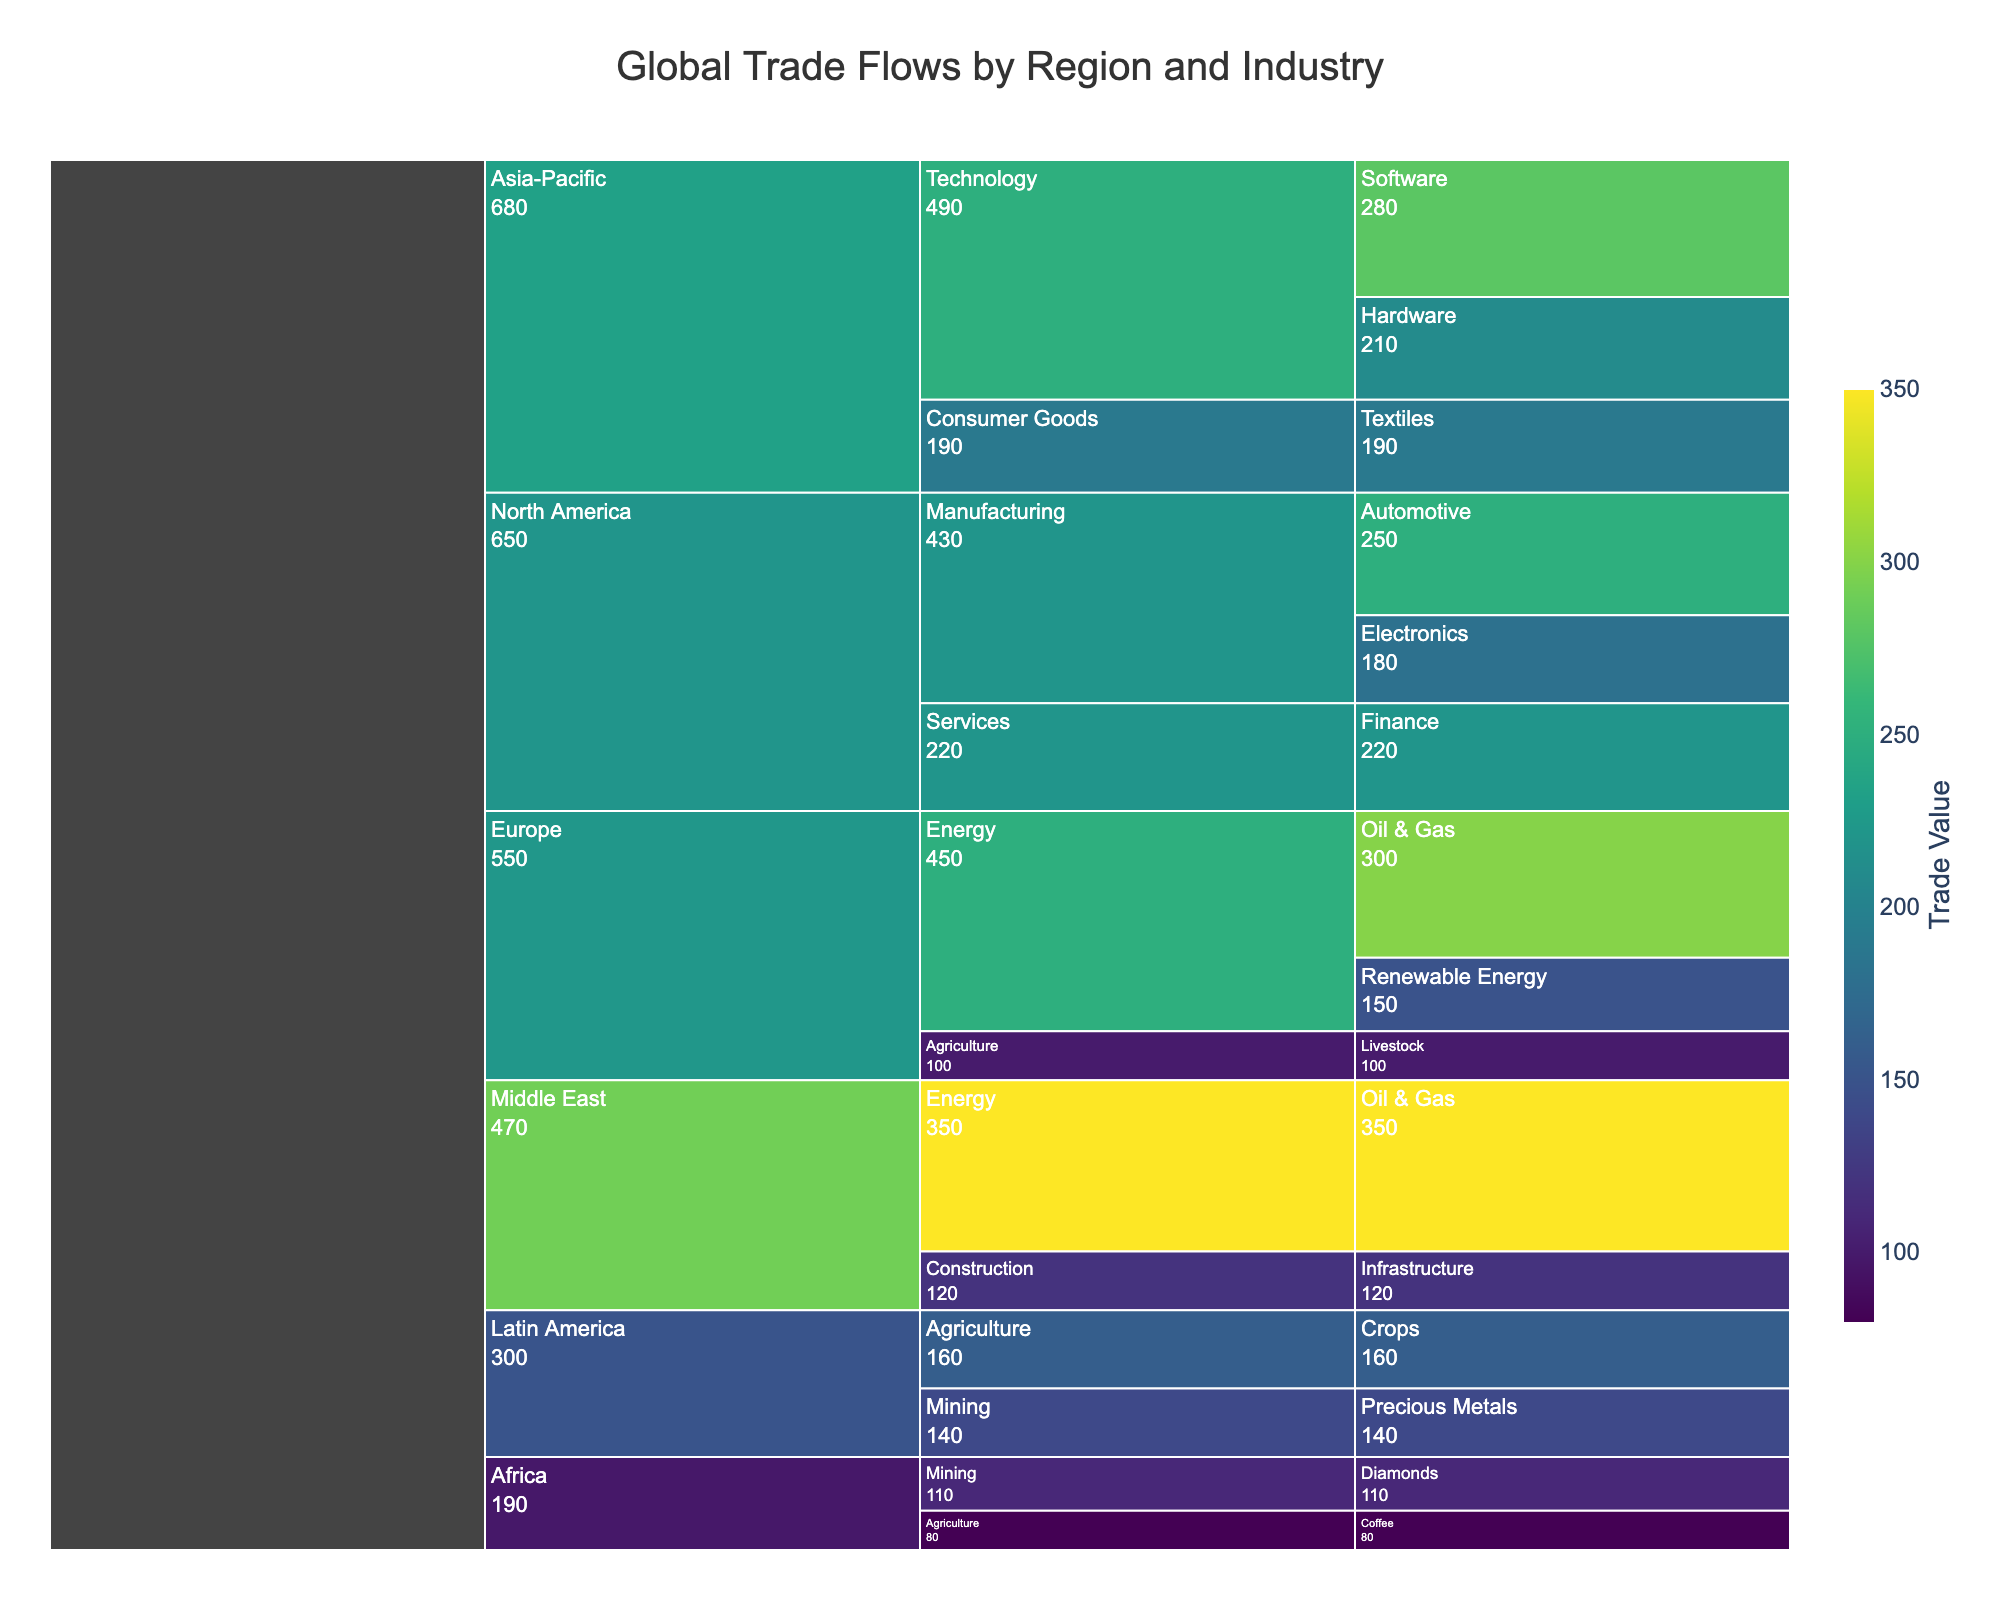Which region has the highest trade value in the Energy sector? The Middle East region has the highest trade value in the Energy sector. By examining the chart, we see that the Middle East Energy sector value is 350, higher than Europe’s Energy sector which adds up to 450 (300+150). The individual states of 350 for Middle East clearly show it is the highest.
Answer: Middle East What is the total trade value of the Agriculture sector across all regions? To find the total trade value, add the values from North America, Europe, Latin America, Africa: North America (Livestock 100) + Europe (Livestock 100) + Latin America (Crops 160) + Africa (Coffee 80) = 440.
Answer: 440 Which sub-industry in Technology within Asia-Pacific has a higher trade value? Compare the values of Software and Hardware within Technology in Asia-Pacific. Software is 280, and Hardware is 210. Thus, Software has a higher trade value.
Answer: Software How does the total trade value in North America compare to that of Europe? Calculate the total trade value in each region: North America (Automotive 250 + Electronics 180 + Finance 220) = 650; Europe (Oil & Gas 300 + Renewable Energy 150 + Livestock 100) = 550. North America's total value (650) is greater than Europe's (550).
Answer: North America has a higher trade value by 100 What is the least valuable sub-industry in Latin America? Examine the sub-industries and their values in Latin America: Crops is valued at 160 and Precious Metals at 140. Precious Metals is the least valuable.
Answer: Precious Metals What is the average trade value of sub-industries within the Technology sector in Asia-Pacific? To find the average, sum the values of Technology sub-industries (Software 280 + Hardware 210) and divide by the number of sub-industries: (280 + 210) / 2 = 245.
Answer: 245 Which region has the largest disparity between its highest and lowest sub-industry trade values? Identify the highest and lowest sub-industry values for each region first. Calculate disparities: North America (250 - 180 = 70), Europe (300 - 100 = 200), Asia-Pacific (280 - 190 = 90), Latin America (160 - 140 = 20), Middle East (350 - 120 = 230), Africa (110 - 80 = 30). The Middle East has the largest disparity of 230.
Answer: Middle East What is the combined trade value of the Automotive and Renewable Energy sub-industries? Sum the values of both sub-industries: Automotive (250) + Renewable Energy (150) = 400.
Answer: 400 How does the total trade value of Consumer Goods in Asia-Pacific compare to the Mining sector in Latin America? Compare the total values of Consumer Goods in Asia-Pacific (Textiles 190) and the Mining sector in Latin America (Precious Metals 140). Textiles's value (190) is greater than Precious Metals's (140).
Answer: Asia-Pacific’s Consumer Goods has a higher trade value by 50 What is the predominant sector in Africa by trade value? Review the sectors in Africa and their total values: Mining (Diamonds 110), Agriculture (Coffee 80). Mining has the highest trade value of 110.
Answer: Mining 